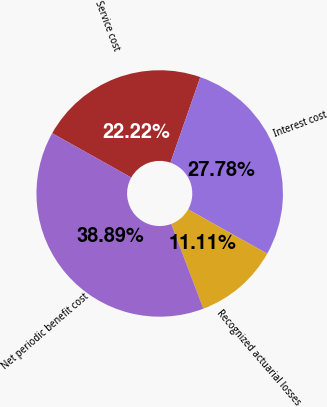Convert chart to OTSL. <chart><loc_0><loc_0><loc_500><loc_500><pie_chart><fcel>Service cost<fcel>Interest cost<fcel>Recognized actuarial losses<fcel>Net periodic benefit cost<nl><fcel>22.22%<fcel>27.78%<fcel>11.11%<fcel>38.89%<nl></chart> 